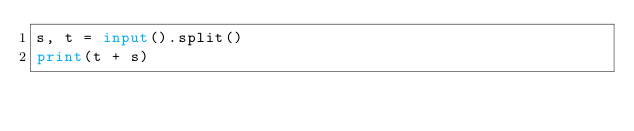<code> <loc_0><loc_0><loc_500><loc_500><_Python_>s, t = input().split()
print(t + s)</code> 